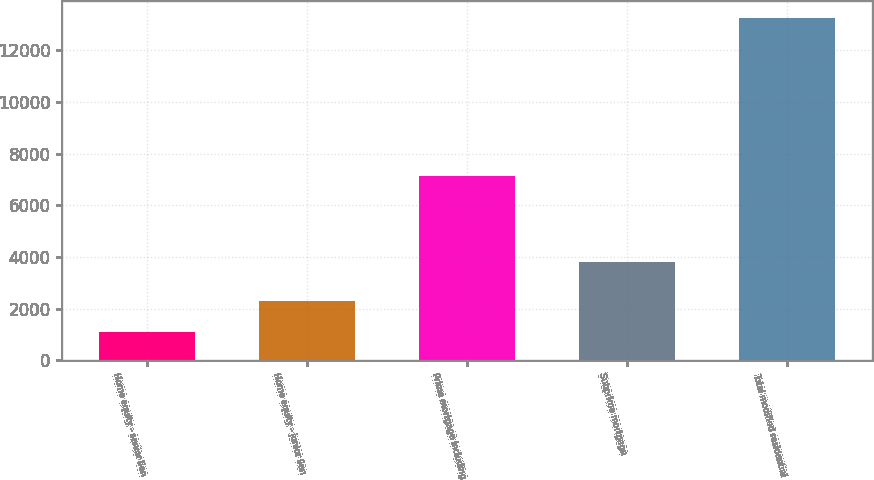Convert chart to OTSL. <chart><loc_0><loc_0><loc_500><loc_500><bar_chart><fcel>Home equity - senior lien<fcel>Home equity - junior lien<fcel>Prime mortgage including<fcel>Subprime mortgage<fcel>Total modified residential<nl><fcel>1092<fcel>2307.3<fcel>7118<fcel>3812<fcel>13245<nl></chart> 